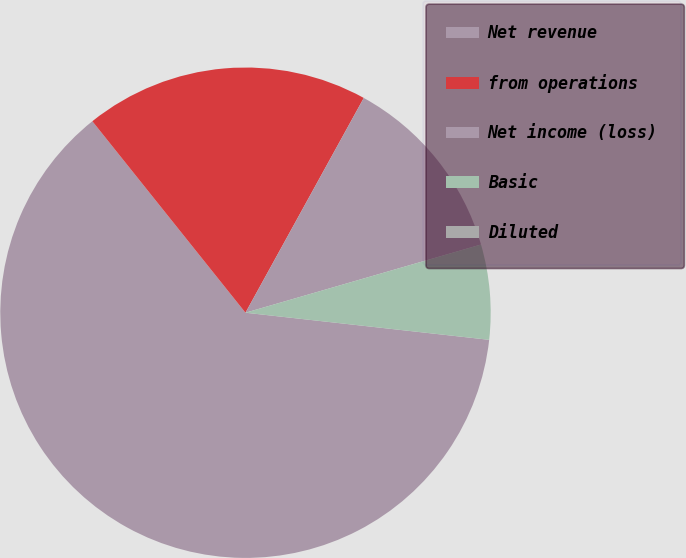Convert chart. <chart><loc_0><loc_0><loc_500><loc_500><pie_chart><fcel>Net revenue<fcel>from operations<fcel>Net income (loss)<fcel>Basic<fcel>Diluted<nl><fcel>62.5%<fcel>18.75%<fcel>12.5%<fcel>6.25%<fcel>0.0%<nl></chart> 